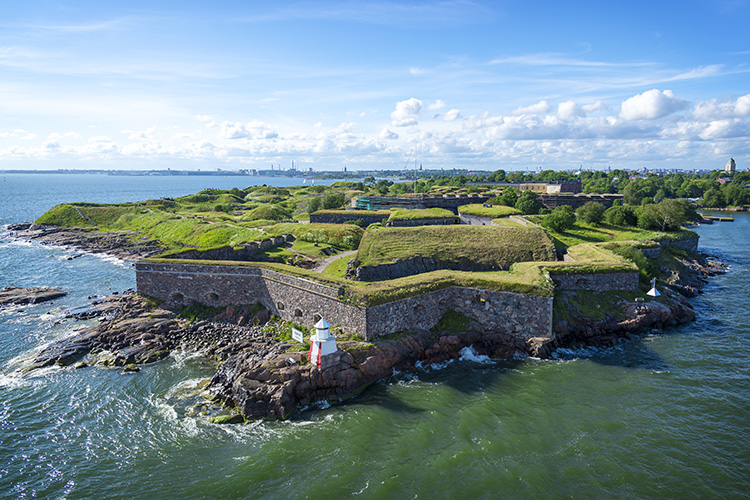Imagine this place in the future; what innovative uses could it have? In the future, Suomenlinna Fortress could transform into a cutting-edge hub for culture, technology, and sustainability. Imagine portions of the fortress housing state-of-the-art research laboratories dedicated to marine biology, leveraging its unique island location. The walls, once used for defense, could be integrated with advanced solar panels, providing a significant amount of renewable energy for the fortress and the surrounding region.

This historical site could also become a cultural bastion, with virtual reality museums bringing its rich history to life for visitors worldwide. Artists and scholars might gather here for international symposia, blending contemporary creativity with historical ambiance. Additionally, parts of the fortress could be converted into eco-friendly accommodations, attracting tourists looking for a unique blend of history, nature, and innovation.

With a focus on sustainability, the fortress could serve as a model for green living, featuring innovative water filtration systems and organic gardens that supply local restaurants. The surrounding waters might be used for marine preservation efforts, supporting the study and conservation of aquatic ecosystems.

Overall, the fortress's future could be a vivid amalgamation of history, culture, and forward-thinking technology, symbolizing the progressive yet respectful stewardship of heritage. What kind of artistic projects can you imagine happening here? Suomenlinna Fortress's scenic and historical backdrop is ideal for a myriad of artistic projects. Imagine large-scale art installations that interact with both the natural and built environment, encouraging visitors to engage with history through contemporary art. The fortress could host annual light festivals, where artists use the stone walls and expansive water surfaces to project mesmerizing light shows and interactive digital art.

Musicians and performers might find inspiration in the fortress’s unique acoustics. Open-air operas, theater performances, and music concerts set against the historic walls could create an unforgettable experience for audiences. The fortress’s rich history could also inspire film directors, turning it into a dynamic film and photography location, with productions ranging from historical dramas to futuristic narratives set in a preserved heritage site.

Workshops and art residencies could invite artists from around the globe to live and create within the fortress, drawing inspiration from its surroundings. This could culminate in an annual arts festival showcasing the fusion of historical and modern artistic expressions. The blend of the old stone architecture and contemporary art could foster a profound appreciation for both the history and forward-thinking creativity of the human spirit. Let's go wild! What if the fortress was inhabited by mythical creatures in a fantasy world? In a fantastical world, Suomenlinna Fortress could be a realm where mythical creatures live in harmony with magical landscapes. Imagine a kingdom where dragons perched atop the fortress walls kept watch over the land, their scales shimmering in the sunlight. Beneath the fortress, hidden tunnels and caves could house a diverse array of creatures like griffins, unicorns, and talking ravens that serve as messengers across the realm.

The grassy areas could be enchanted, where flowers bloom with bioluminescent light at dusk, and rivers around the fortress teem with mermaids and water sprites. The fortress's human inhabitants might be powerful wizards and sorcerers, whose magical spells protect the land and keep balance with nature. The city of Helsinki in the distance could be a bustling market town where humans and mythical beings trade goods, potions, and enchanted artifacts.

Legend tells of an ancient tree at the fortress’s heart, whose roots are the source of all magic in the land. This tree might be guarded by an order of knights, sworn to protect it and ensure that its power is used only for good. Festivals are held where these magical creatures and beings come together, celebrating their unity and the mysteries of the ancient fortress. This vibrant, enchanted world turns Suomenlinna into a place where history, magic, and myth coalesce in a breathtaking narrative of wonder.  Describe a peaceful day at the Suomenlinna Fortress. On a tranquil day, Suomenlinna Fortress is bathed in the warm glow of the morning sun. The gentle sound of waves lapping against the shore creates a serene soundtrack, while a light breeze rustles through the grass. Birds chirp melodiously, adding to the peaceful ambiance.

Strolling along the fortress walls, visitors are greeted by stunning views of the calm sea, its surface reflecting the few scattered clouds above. Families enjoy picnics on the grassy areas, and children play, reveling in the open space and fresh air. Artists set up their easels, capturing the beauty of the historic structure and its surroundings on canvas.

In the quiet moments, the fortress feels timeless, a blend of natural beauty and historical significance providing a sense of calm and reflection. The city of Helsinki in the distance adds to the picturesque scenery without disrupting the tranquility of the fortress. As the day progresses, the fortress remains a peaceful haven, allowing visitors and locals alike to connect with nature and history in harmonious simplicity.  What could be a brief historical significance of the Suomenlinna Fortress? Suomenlinna Fortress, constructed in the mid-18th century, stands as a critical historical and strategic maritime fortification. Originally built by the Swedish Kingdom to protect against Russian expansion, the fortress reflects the military architectural prowess of its time. It played a significant role in various conflicts and has since become a symbol of cultural heritage and resilience. Today, as a UNESCO World Heritage Site, it represents the complex historical narratives of the region and serves as an enduring reminder of past struggles and achievements in maritime defense and diplomacy. 